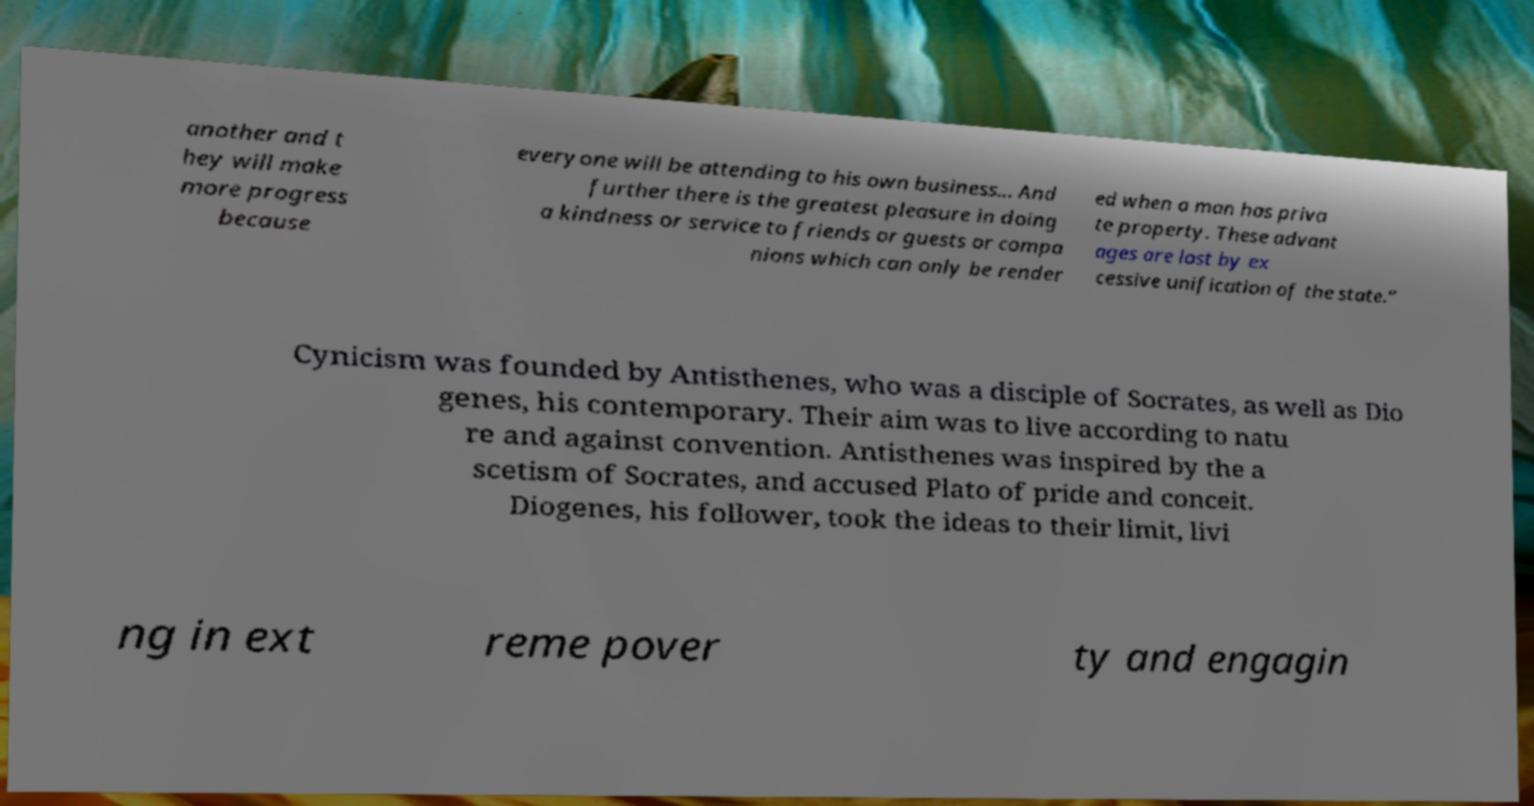Can you accurately transcribe the text from the provided image for me? another and t hey will make more progress because everyone will be attending to his own business... And further there is the greatest pleasure in doing a kindness or service to friends or guests or compa nions which can only be render ed when a man has priva te property. These advant ages are lost by ex cessive unification of the state.” Cynicism was founded by Antisthenes, who was a disciple of Socrates, as well as Dio genes, his contemporary. Their aim was to live according to natu re and against convention. Antisthenes was inspired by the a scetism of Socrates, and accused Plato of pride and conceit. Diogenes, his follower, took the ideas to their limit, livi ng in ext reme pover ty and engagin 